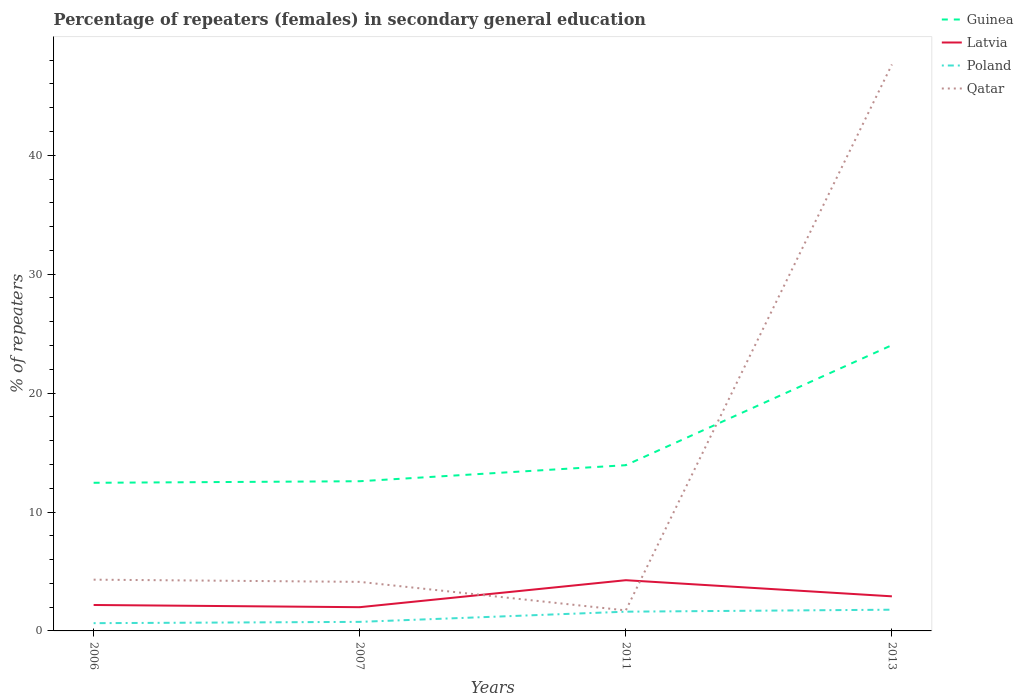Does the line corresponding to Latvia intersect with the line corresponding to Qatar?
Ensure brevity in your answer.  Yes. Across all years, what is the maximum percentage of female repeaters in Qatar?
Give a very brief answer. 1.73. In which year was the percentage of female repeaters in Guinea maximum?
Provide a short and direct response. 2006. What is the total percentage of female repeaters in Qatar in the graph?
Ensure brevity in your answer.  2.58. What is the difference between the highest and the second highest percentage of female repeaters in Latvia?
Offer a very short reply. 2.27. How many lines are there?
Your answer should be very brief. 4. How many years are there in the graph?
Offer a terse response. 4. Are the values on the major ticks of Y-axis written in scientific E-notation?
Your answer should be compact. No. Does the graph contain any zero values?
Ensure brevity in your answer.  No. Where does the legend appear in the graph?
Offer a terse response. Top right. What is the title of the graph?
Provide a short and direct response. Percentage of repeaters (females) in secondary general education. Does "Djibouti" appear as one of the legend labels in the graph?
Offer a terse response. No. What is the label or title of the X-axis?
Your response must be concise. Years. What is the label or title of the Y-axis?
Provide a short and direct response. % of repeaters. What is the % of repeaters in Guinea in 2006?
Your answer should be very brief. 12.46. What is the % of repeaters of Latvia in 2006?
Give a very brief answer. 2.18. What is the % of repeaters of Poland in 2006?
Ensure brevity in your answer.  0.65. What is the % of repeaters of Qatar in 2006?
Offer a terse response. 4.31. What is the % of repeaters of Guinea in 2007?
Make the answer very short. 12.59. What is the % of repeaters of Latvia in 2007?
Keep it short and to the point. 2. What is the % of repeaters in Poland in 2007?
Ensure brevity in your answer.  0.76. What is the % of repeaters of Qatar in 2007?
Provide a succinct answer. 4.13. What is the % of repeaters of Guinea in 2011?
Your answer should be compact. 13.94. What is the % of repeaters of Latvia in 2011?
Keep it short and to the point. 4.27. What is the % of repeaters of Poland in 2011?
Offer a terse response. 1.62. What is the % of repeaters in Qatar in 2011?
Your response must be concise. 1.73. What is the % of repeaters in Guinea in 2013?
Give a very brief answer. 24.03. What is the % of repeaters of Latvia in 2013?
Your answer should be compact. 2.91. What is the % of repeaters of Poland in 2013?
Your answer should be compact. 1.78. What is the % of repeaters in Qatar in 2013?
Ensure brevity in your answer.  47.64. Across all years, what is the maximum % of repeaters in Guinea?
Your answer should be very brief. 24.03. Across all years, what is the maximum % of repeaters of Latvia?
Keep it short and to the point. 4.27. Across all years, what is the maximum % of repeaters in Poland?
Make the answer very short. 1.78. Across all years, what is the maximum % of repeaters in Qatar?
Provide a succinct answer. 47.64. Across all years, what is the minimum % of repeaters of Guinea?
Provide a short and direct response. 12.46. Across all years, what is the minimum % of repeaters of Latvia?
Make the answer very short. 2. Across all years, what is the minimum % of repeaters of Poland?
Give a very brief answer. 0.65. Across all years, what is the minimum % of repeaters of Qatar?
Your answer should be very brief. 1.73. What is the total % of repeaters of Guinea in the graph?
Ensure brevity in your answer.  63.02. What is the total % of repeaters of Latvia in the graph?
Keep it short and to the point. 11.35. What is the total % of repeaters in Poland in the graph?
Make the answer very short. 4.82. What is the total % of repeaters in Qatar in the graph?
Offer a very short reply. 57.8. What is the difference between the % of repeaters in Guinea in 2006 and that in 2007?
Your answer should be very brief. -0.13. What is the difference between the % of repeaters of Latvia in 2006 and that in 2007?
Your answer should be compact. 0.19. What is the difference between the % of repeaters in Poland in 2006 and that in 2007?
Keep it short and to the point. -0.11. What is the difference between the % of repeaters of Qatar in 2006 and that in 2007?
Your response must be concise. 0.18. What is the difference between the % of repeaters in Guinea in 2006 and that in 2011?
Provide a short and direct response. -1.48. What is the difference between the % of repeaters in Latvia in 2006 and that in 2011?
Your response must be concise. -2.08. What is the difference between the % of repeaters in Poland in 2006 and that in 2011?
Your answer should be very brief. -0.97. What is the difference between the % of repeaters of Qatar in 2006 and that in 2011?
Give a very brief answer. 2.58. What is the difference between the % of repeaters in Guinea in 2006 and that in 2013?
Your response must be concise. -11.58. What is the difference between the % of repeaters in Latvia in 2006 and that in 2013?
Give a very brief answer. -0.73. What is the difference between the % of repeaters in Poland in 2006 and that in 2013?
Your response must be concise. -1.13. What is the difference between the % of repeaters in Qatar in 2006 and that in 2013?
Keep it short and to the point. -43.33. What is the difference between the % of repeaters in Guinea in 2007 and that in 2011?
Your answer should be very brief. -1.35. What is the difference between the % of repeaters of Latvia in 2007 and that in 2011?
Your answer should be compact. -2.27. What is the difference between the % of repeaters of Poland in 2007 and that in 2011?
Offer a terse response. -0.86. What is the difference between the % of repeaters of Qatar in 2007 and that in 2011?
Ensure brevity in your answer.  2.4. What is the difference between the % of repeaters of Guinea in 2007 and that in 2013?
Provide a short and direct response. -11.44. What is the difference between the % of repeaters of Latvia in 2007 and that in 2013?
Your answer should be compact. -0.91. What is the difference between the % of repeaters of Poland in 2007 and that in 2013?
Your answer should be compact. -1.02. What is the difference between the % of repeaters in Qatar in 2007 and that in 2013?
Your response must be concise. -43.51. What is the difference between the % of repeaters of Guinea in 2011 and that in 2013?
Make the answer very short. -10.1. What is the difference between the % of repeaters in Latvia in 2011 and that in 2013?
Provide a succinct answer. 1.36. What is the difference between the % of repeaters of Poland in 2011 and that in 2013?
Provide a short and direct response. -0.17. What is the difference between the % of repeaters of Qatar in 2011 and that in 2013?
Ensure brevity in your answer.  -45.91. What is the difference between the % of repeaters in Guinea in 2006 and the % of repeaters in Latvia in 2007?
Ensure brevity in your answer.  10.46. What is the difference between the % of repeaters in Guinea in 2006 and the % of repeaters in Poland in 2007?
Provide a short and direct response. 11.7. What is the difference between the % of repeaters of Guinea in 2006 and the % of repeaters of Qatar in 2007?
Keep it short and to the point. 8.33. What is the difference between the % of repeaters in Latvia in 2006 and the % of repeaters in Poland in 2007?
Provide a succinct answer. 1.42. What is the difference between the % of repeaters in Latvia in 2006 and the % of repeaters in Qatar in 2007?
Provide a short and direct response. -1.94. What is the difference between the % of repeaters in Poland in 2006 and the % of repeaters in Qatar in 2007?
Provide a succinct answer. -3.47. What is the difference between the % of repeaters in Guinea in 2006 and the % of repeaters in Latvia in 2011?
Provide a succinct answer. 8.19. What is the difference between the % of repeaters of Guinea in 2006 and the % of repeaters of Poland in 2011?
Ensure brevity in your answer.  10.84. What is the difference between the % of repeaters of Guinea in 2006 and the % of repeaters of Qatar in 2011?
Make the answer very short. 10.73. What is the difference between the % of repeaters in Latvia in 2006 and the % of repeaters in Poland in 2011?
Your answer should be compact. 0.56. What is the difference between the % of repeaters in Latvia in 2006 and the % of repeaters in Qatar in 2011?
Keep it short and to the point. 0.46. What is the difference between the % of repeaters of Poland in 2006 and the % of repeaters of Qatar in 2011?
Your answer should be very brief. -1.07. What is the difference between the % of repeaters of Guinea in 2006 and the % of repeaters of Latvia in 2013?
Your answer should be compact. 9.55. What is the difference between the % of repeaters of Guinea in 2006 and the % of repeaters of Poland in 2013?
Offer a very short reply. 10.67. What is the difference between the % of repeaters in Guinea in 2006 and the % of repeaters in Qatar in 2013?
Your answer should be compact. -35.18. What is the difference between the % of repeaters of Latvia in 2006 and the % of repeaters of Poland in 2013?
Offer a very short reply. 0.4. What is the difference between the % of repeaters of Latvia in 2006 and the % of repeaters of Qatar in 2013?
Give a very brief answer. -45.46. What is the difference between the % of repeaters in Poland in 2006 and the % of repeaters in Qatar in 2013?
Offer a terse response. -46.99. What is the difference between the % of repeaters of Guinea in 2007 and the % of repeaters of Latvia in 2011?
Offer a very short reply. 8.32. What is the difference between the % of repeaters of Guinea in 2007 and the % of repeaters of Poland in 2011?
Your response must be concise. 10.97. What is the difference between the % of repeaters in Guinea in 2007 and the % of repeaters in Qatar in 2011?
Keep it short and to the point. 10.86. What is the difference between the % of repeaters in Latvia in 2007 and the % of repeaters in Poland in 2011?
Your answer should be very brief. 0.38. What is the difference between the % of repeaters of Latvia in 2007 and the % of repeaters of Qatar in 2011?
Offer a terse response. 0.27. What is the difference between the % of repeaters of Poland in 2007 and the % of repeaters of Qatar in 2011?
Offer a very short reply. -0.96. What is the difference between the % of repeaters of Guinea in 2007 and the % of repeaters of Latvia in 2013?
Keep it short and to the point. 9.68. What is the difference between the % of repeaters in Guinea in 2007 and the % of repeaters in Poland in 2013?
Your response must be concise. 10.81. What is the difference between the % of repeaters in Guinea in 2007 and the % of repeaters in Qatar in 2013?
Your answer should be compact. -35.05. What is the difference between the % of repeaters in Latvia in 2007 and the % of repeaters in Poland in 2013?
Keep it short and to the point. 0.21. What is the difference between the % of repeaters in Latvia in 2007 and the % of repeaters in Qatar in 2013?
Your answer should be very brief. -45.64. What is the difference between the % of repeaters in Poland in 2007 and the % of repeaters in Qatar in 2013?
Keep it short and to the point. -46.88. What is the difference between the % of repeaters of Guinea in 2011 and the % of repeaters of Latvia in 2013?
Provide a short and direct response. 11.03. What is the difference between the % of repeaters of Guinea in 2011 and the % of repeaters of Poland in 2013?
Provide a short and direct response. 12.15. What is the difference between the % of repeaters of Guinea in 2011 and the % of repeaters of Qatar in 2013?
Make the answer very short. -33.7. What is the difference between the % of repeaters in Latvia in 2011 and the % of repeaters in Poland in 2013?
Provide a succinct answer. 2.48. What is the difference between the % of repeaters of Latvia in 2011 and the % of repeaters of Qatar in 2013?
Ensure brevity in your answer.  -43.37. What is the difference between the % of repeaters in Poland in 2011 and the % of repeaters in Qatar in 2013?
Your answer should be compact. -46.02. What is the average % of repeaters in Guinea per year?
Give a very brief answer. 15.76. What is the average % of repeaters in Latvia per year?
Your response must be concise. 2.84. What is the average % of repeaters of Poland per year?
Make the answer very short. 1.2. What is the average % of repeaters of Qatar per year?
Your answer should be compact. 14.45. In the year 2006, what is the difference between the % of repeaters in Guinea and % of repeaters in Latvia?
Your answer should be compact. 10.28. In the year 2006, what is the difference between the % of repeaters in Guinea and % of repeaters in Poland?
Your answer should be compact. 11.81. In the year 2006, what is the difference between the % of repeaters of Guinea and % of repeaters of Qatar?
Offer a very short reply. 8.15. In the year 2006, what is the difference between the % of repeaters of Latvia and % of repeaters of Poland?
Offer a terse response. 1.53. In the year 2006, what is the difference between the % of repeaters in Latvia and % of repeaters in Qatar?
Provide a succinct answer. -2.13. In the year 2006, what is the difference between the % of repeaters of Poland and % of repeaters of Qatar?
Provide a succinct answer. -3.66. In the year 2007, what is the difference between the % of repeaters in Guinea and % of repeaters in Latvia?
Your answer should be compact. 10.59. In the year 2007, what is the difference between the % of repeaters of Guinea and % of repeaters of Poland?
Your answer should be very brief. 11.83. In the year 2007, what is the difference between the % of repeaters of Guinea and % of repeaters of Qatar?
Ensure brevity in your answer.  8.46. In the year 2007, what is the difference between the % of repeaters of Latvia and % of repeaters of Poland?
Offer a terse response. 1.23. In the year 2007, what is the difference between the % of repeaters of Latvia and % of repeaters of Qatar?
Your response must be concise. -2.13. In the year 2007, what is the difference between the % of repeaters of Poland and % of repeaters of Qatar?
Give a very brief answer. -3.36. In the year 2011, what is the difference between the % of repeaters of Guinea and % of repeaters of Latvia?
Provide a short and direct response. 9.67. In the year 2011, what is the difference between the % of repeaters of Guinea and % of repeaters of Poland?
Ensure brevity in your answer.  12.32. In the year 2011, what is the difference between the % of repeaters of Guinea and % of repeaters of Qatar?
Provide a short and direct response. 12.21. In the year 2011, what is the difference between the % of repeaters of Latvia and % of repeaters of Poland?
Keep it short and to the point. 2.65. In the year 2011, what is the difference between the % of repeaters in Latvia and % of repeaters in Qatar?
Your answer should be compact. 2.54. In the year 2011, what is the difference between the % of repeaters of Poland and % of repeaters of Qatar?
Provide a succinct answer. -0.11. In the year 2013, what is the difference between the % of repeaters of Guinea and % of repeaters of Latvia?
Offer a very short reply. 21.12. In the year 2013, what is the difference between the % of repeaters of Guinea and % of repeaters of Poland?
Offer a terse response. 22.25. In the year 2013, what is the difference between the % of repeaters of Guinea and % of repeaters of Qatar?
Offer a very short reply. -23.6. In the year 2013, what is the difference between the % of repeaters of Latvia and % of repeaters of Poland?
Keep it short and to the point. 1.12. In the year 2013, what is the difference between the % of repeaters of Latvia and % of repeaters of Qatar?
Offer a terse response. -44.73. In the year 2013, what is the difference between the % of repeaters in Poland and % of repeaters in Qatar?
Make the answer very short. -45.85. What is the ratio of the % of repeaters in Guinea in 2006 to that in 2007?
Give a very brief answer. 0.99. What is the ratio of the % of repeaters of Latvia in 2006 to that in 2007?
Your response must be concise. 1.09. What is the ratio of the % of repeaters in Poland in 2006 to that in 2007?
Your answer should be very brief. 0.86. What is the ratio of the % of repeaters in Qatar in 2006 to that in 2007?
Keep it short and to the point. 1.04. What is the ratio of the % of repeaters in Guinea in 2006 to that in 2011?
Make the answer very short. 0.89. What is the ratio of the % of repeaters in Latvia in 2006 to that in 2011?
Your answer should be compact. 0.51. What is the ratio of the % of repeaters of Poland in 2006 to that in 2011?
Your answer should be compact. 0.4. What is the ratio of the % of repeaters in Qatar in 2006 to that in 2011?
Give a very brief answer. 2.5. What is the ratio of the % of repeaters in Guinea in 2006 to that in 2013?
Your response must be concise. 0.52. What is the ratio of the % of repeaters of Latvia in 2006 to that in 2013?
Ensure brevity in your answer.  0.75. What is the ratio of the % of repeaters of Poland in 2006 to that in 2013?
Offer a very short reply. 0.37. What is the ratio of the % of repeaters of Qatar in 2006 to that in 2013?
Keep it short and to the point. 0.09. What is the ratio of the % of repeaters of Guinea in 2007 to that in 2011?
Provide a short and direct response. 0.9. What is the ratio of the % of repeaters in Latvia in 2007 to that in 2011?
Offer a very short reply. 0.47. What is the ratio of the % of repeaters in Poland in 2007 to that in 2011?
Offer a very short reply. 0.47. What is the ratio of the % of repeaters in Qatar in 2007 to that in 2011?
Offer a terse response. 2.39. What is the ratio of the % of repeaters in Guinea in 2007 to that in 2013?
Your answer should be very brief. 0.52. What is the ratio of the % of repeaters in Latvia in 2007 to that in 2013?
Offer a terse response. 0.69. What is the ratio of the % of repeaters of Poland in 2007 to that in 2013?
Offer a very short reply. 0.43. What is the ratio of the % of repeaters in Qatar in 2007 to that in 2013?
Make the answer very short. 0.09. What is the ratio of the % of repeaters in Guinea in 2011 to that in 2013?
Offer a very short reply. 0.58. What is the ratio of the % of repeaters in Latvia in 2011 to that in 2013?
Provide a succinct answer. 1.47. What is the ratio of the % of repeaters in Poland in 2011 to that in 2013?
Provide a short and direct response. 0.91. What is the ratio of the % of repeaters of Qatar in 2011 to that in 2013?
Your answer should be very brief. 0.04. What is the difference between the highest and the second highest % of repeaters in Guinea?
Keep it short and to the point. 10.1. What is the difference between the highest and the second highest % of repeaters of Latvia?
Keep it short and to the point. 1.36. What is the difference between the highest and the second highest % of repeaters of Poland?
Ensure brevity in your answer.  0.17. What is the difference between the highest and the second highest % of repeaters of Qatar?
Provide a succinct answer. 43.33. What is the difference between the highest and the lowest % of repeaters in Guinea?
Give a very brief answer. 11.58. What is the difference between the highest and the lowest % of repeaters of Latvia?
Offer a very short reply. 2.27. What is the difference between the highest and the lowest % of repeaters in Poland?
Give a very brief answer. 1.13. What is the difference between the highest and the lowest % of repeaters in Qatar?
Your answer should be very brief. 45.91. 